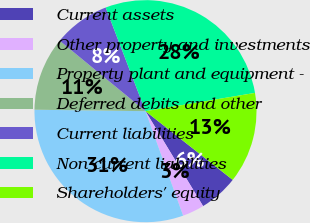<chart> <loc_0><loc_0><loc_500><loc_500><pie_chart><fcel>Current assets<fcel>Other property and investments<fcel>Property plant and equipment -<fcel>Deferred debits and other<fcel>Current liabilities<fcel>Non-current liabilities<fcel>Shareholders' equity<nl><fcel>5.7%<fcel>3.18%<fcel>30.71%<fcel>10.73%<fcel>8.22%<fcel>28.2%<fcel>13.25%<nl></chart> 